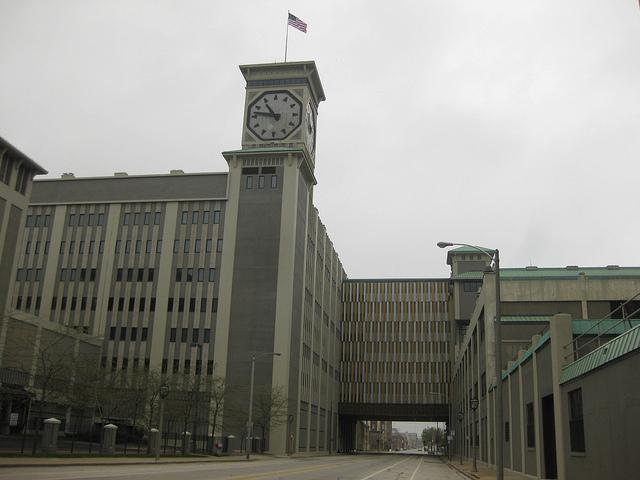How many stories is this building?
Keep it brief. 3. How many people are on the roof?
Answer briefly. 0. Is this a busy street?
Concise answer only. No. Is the sky cloudy?
Answer briefly. Yes. Does the building show reflection?
Short answer required. No. What is the tall building?
Give a very brief answer. Clock tower. Is this a mall?
Answer briefly. No. What is the country of the flag on top of the clock tower?
Keep it brief. Usa. What is at the top the building?
Short answer required. Flag. What color of the lamppost?
Be succinct. Gray. Is there a light on?
Keep it brief. No. Is there a picture of old building?
Concise answer only. Yes. Are there any living things pictured?
Concise answer only. No. What color are the train tracks above the clock?
Concise answer only. White. Could this be on-going construction?
Quick response, please. No. What time is it?
Give a very brief answer. 10:45. What kind of building is this?
Keep it brief. Office. How many windows are on the building?
Answer briefly. Many. Is this an old building?
Give a very brief answer. No. What is building on the far left composed of?
Answer briefly. Concrete. What colors are the clocks?
Write a very short answer. White. What is way on top of the roof, a piece of equipment?
Keep it brief. Flag. What symbol is on top of the tower?
Quick response, please. American flag. Where is the archway?
Be succinct. Over road. How many buildings are in the shot?
Short answer required. 2. Is the clock over water?
Quick response, please. No. Is this a Chinese gate?
Keep it brief. No. What type of architecture is the building?
Give a very brief answer. Modern. What is the time?
Answer briefly. 10:46. Are there any palm trees in this picture?
Concise answer only. No. What time does the clock say?
Answer briefly. 10:46. Is this a sunny day?
Write a very short answer. No. Is this a scene you would see if you were in Italy?
Short answer required. No. Where do you see a clock?
Be succinct. Tower. How many towers high is the building in middle?
Be succinct. 1. Is there a roundabout here?
Keep it brief. No. How many stories does the building in the background have?
Short answer required. 7. How many scrolls beneath the lamp are oriented like the letter S?
Keep it brief. 0. Is there a trash can visible?
Be succinct. No. What color is the brick?
Quick response, please. Gray. Is it raining?
Concise answer only. No. Is the time correct?
Give a very brief answer. Yes. Where is the crane?
Keep it brief. Nowhere. Is there construction going on?
Answer briefly. No. Where was the picture taken?
Be succinct. Downtown. Is there a reflection?
Answer briefly. No. What time is it on this clock?
Be succinct. 10:45. What color is the building?
Answer briefly. Gray. Is there a tree in this picture?
Write a very short answer. Yes. Is it sunny?
Be succinct. No. 